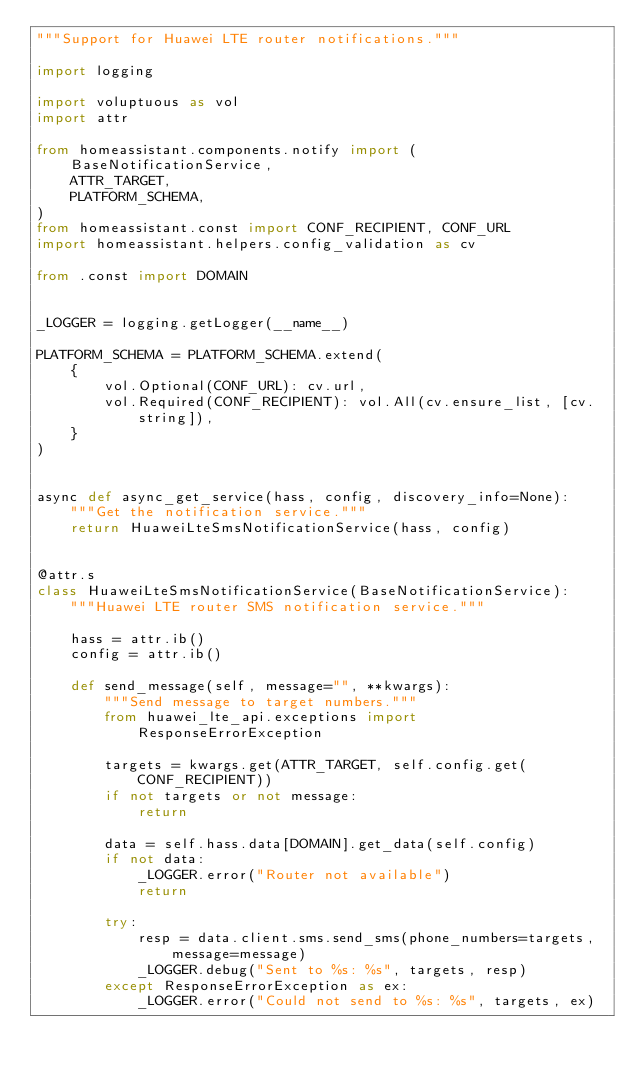<code> <loc_0><loc_0><loc_500><loc_500><_Python_>"""Support for Huawei LTE router notifications."""

import logging

import voluptuous as vol
import attr

from homeassistant.components.notify import (
    BaseNotificationService,
    ATTR_TARGET,
    PLATFORM_SCHEMA,
)
from homeassistant.const import CONF_RECIPIENT, CONF_URL
import homeassistant.helpers.config_validation as cv

from .const import DOMAIN


_LOGGER = logging.getLogger(__name__)

PLATFORM_SCHEMA = PLATFORM_SCHEMA.extend(
    {
        vol.Optional(CONF_URL): cv.url,
        vol.Required(CONF_RECIPIENT): vol.All(cv.ensure_list, [cv.string]),
    }
)


async def async_get_service(hass, config, discovery_info=None):
    """Get the notification service."""
    return HuaweiLteSmsNotificationService(hass, config)


@attr.s
class HuaweiLteSmsNotificationService(BaseNotificationService):
    """Huawei LTE router SMS notification service."""

    hass = attr.ib()
    config = attr.ib()

    def send_message(self, message="", **kwargs):
        """Send message to target numbers."""
        from huawei_lte_api.exceptions import ResponseErrorException

        targets = kwargs.get(ATTR_TARGET, self.config.get(CONF_RECIPIENT))
        if not targets or not message:
            return

        data = self.hass.data[DOMAIN].get_data(self.config)
        if not data:
            _LOGGER.error("Router not available")
            return

        try:
            resp = data.client.sms.send_sms(phone_numbers=targets, message=message)
            _LOGGER.debug("Sent to %s: %s", targets, resp)
        except ResponseErrorException as ex:
            _LOGGER.error("Could not send to %s: %s", targets, ex)
</code> 